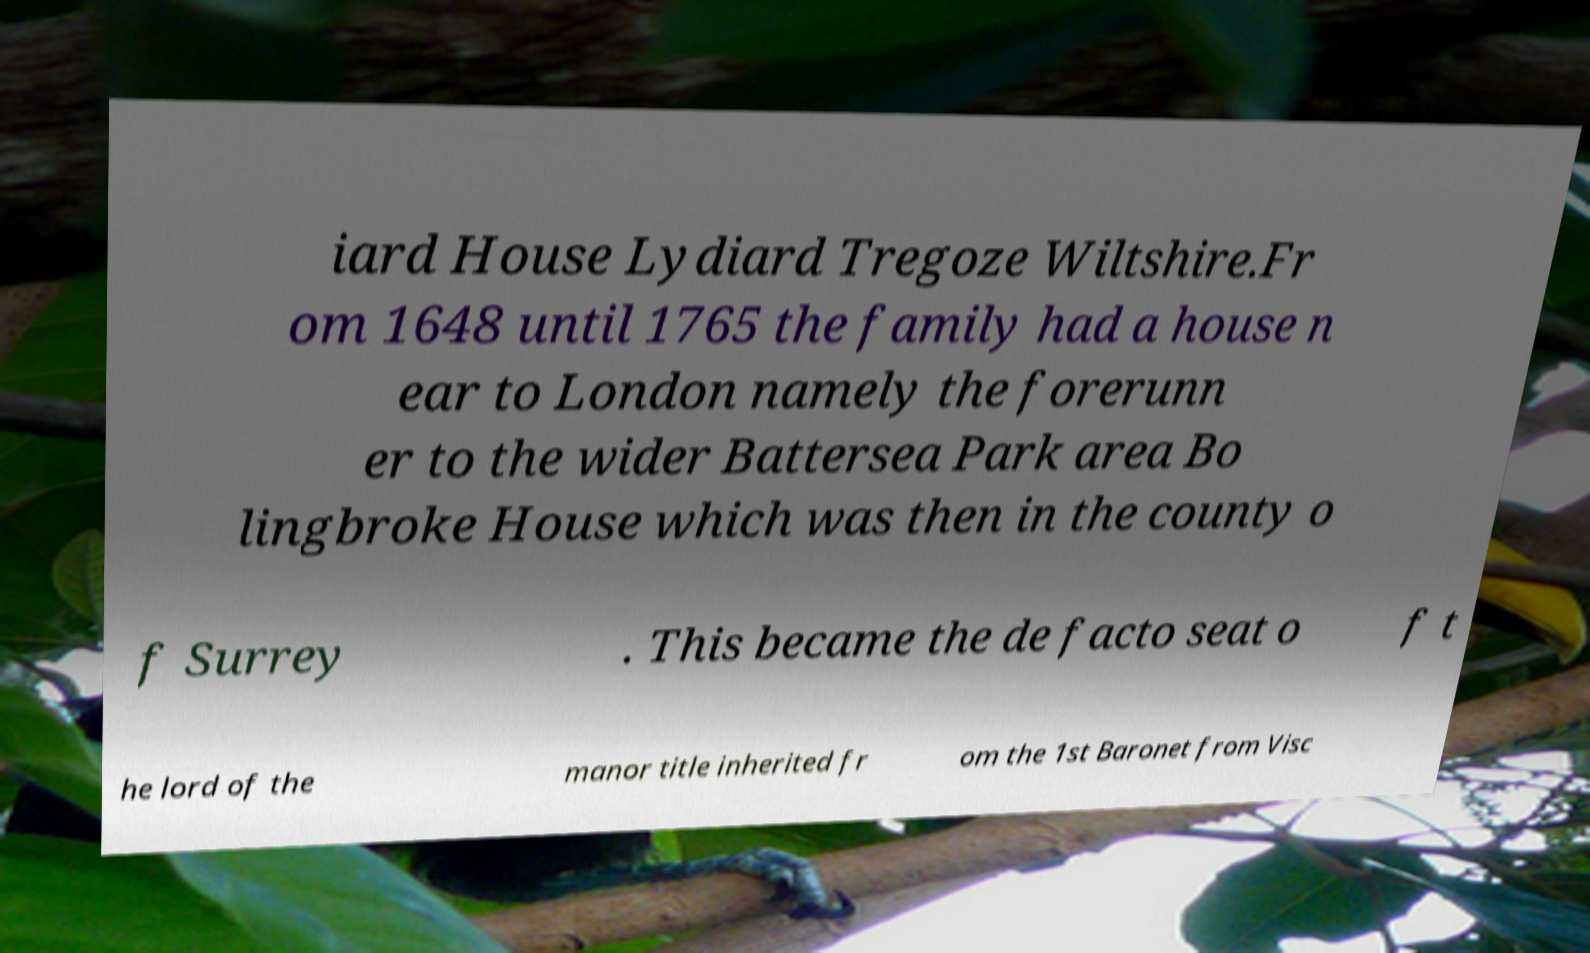Please identify and transcribe the text found in this image. iard House Lydiard Tregoze Wiltshire.Fr om 1648 until 1765 the family had a house n ear to London namely the forerunn er to the wider Battersea Park area Bo lingbroke House which was then in the county o f Surrey . This became the de facto seat o f t he lord of the manor title inherited fr om the 1st Baronet from Visc 